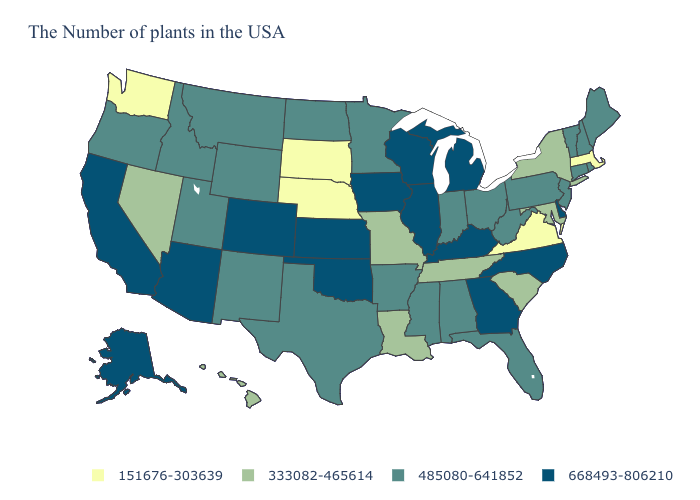What is the lowest value in the USA?
Write a very short answer. 151676-303639. Name the states that have a value in the range 151676-303639?
Keep it brief. Massachusetts, Virginia, Nebraska, South Dakota, Washington. Does Colorado have the highest value in the USA?
Write a very short answer. Yes. What is the value of Wisconsin?
Give a very brief answer. 668493-806210. What is the highest value in the West ?
Answer briefly. 668493-806210. Which states have the lowest value in the USA?
Write a very short answer. Massachusetts, Virginia, Nebraska, South Dakota, Washington. What is the lowest value in the South?
Keep it brief. 151676-303639. Does Rhode Island have the lowest value in the USA?
Give a very brief answer. No. Does North Dakota have the same value as Texas?
Quick response, please. Yes. Among the states that border Michigan , which have the lowest value?
Answer briefly. Ohio, Indiana. Does Virginia have the lowest value in the USA?
Answer briefly. Yes. Among the states that border Ohio , does Michigan have the highest value?
Short answer required. Yes. Does Iowa have a higher value than New Jersey?
Give a very brief answer. Yes. What is the value of North Dakota?
Answer briefly. 485080-641852. What is the highest value in the USA?
Keep it brief. 668493-806210. 